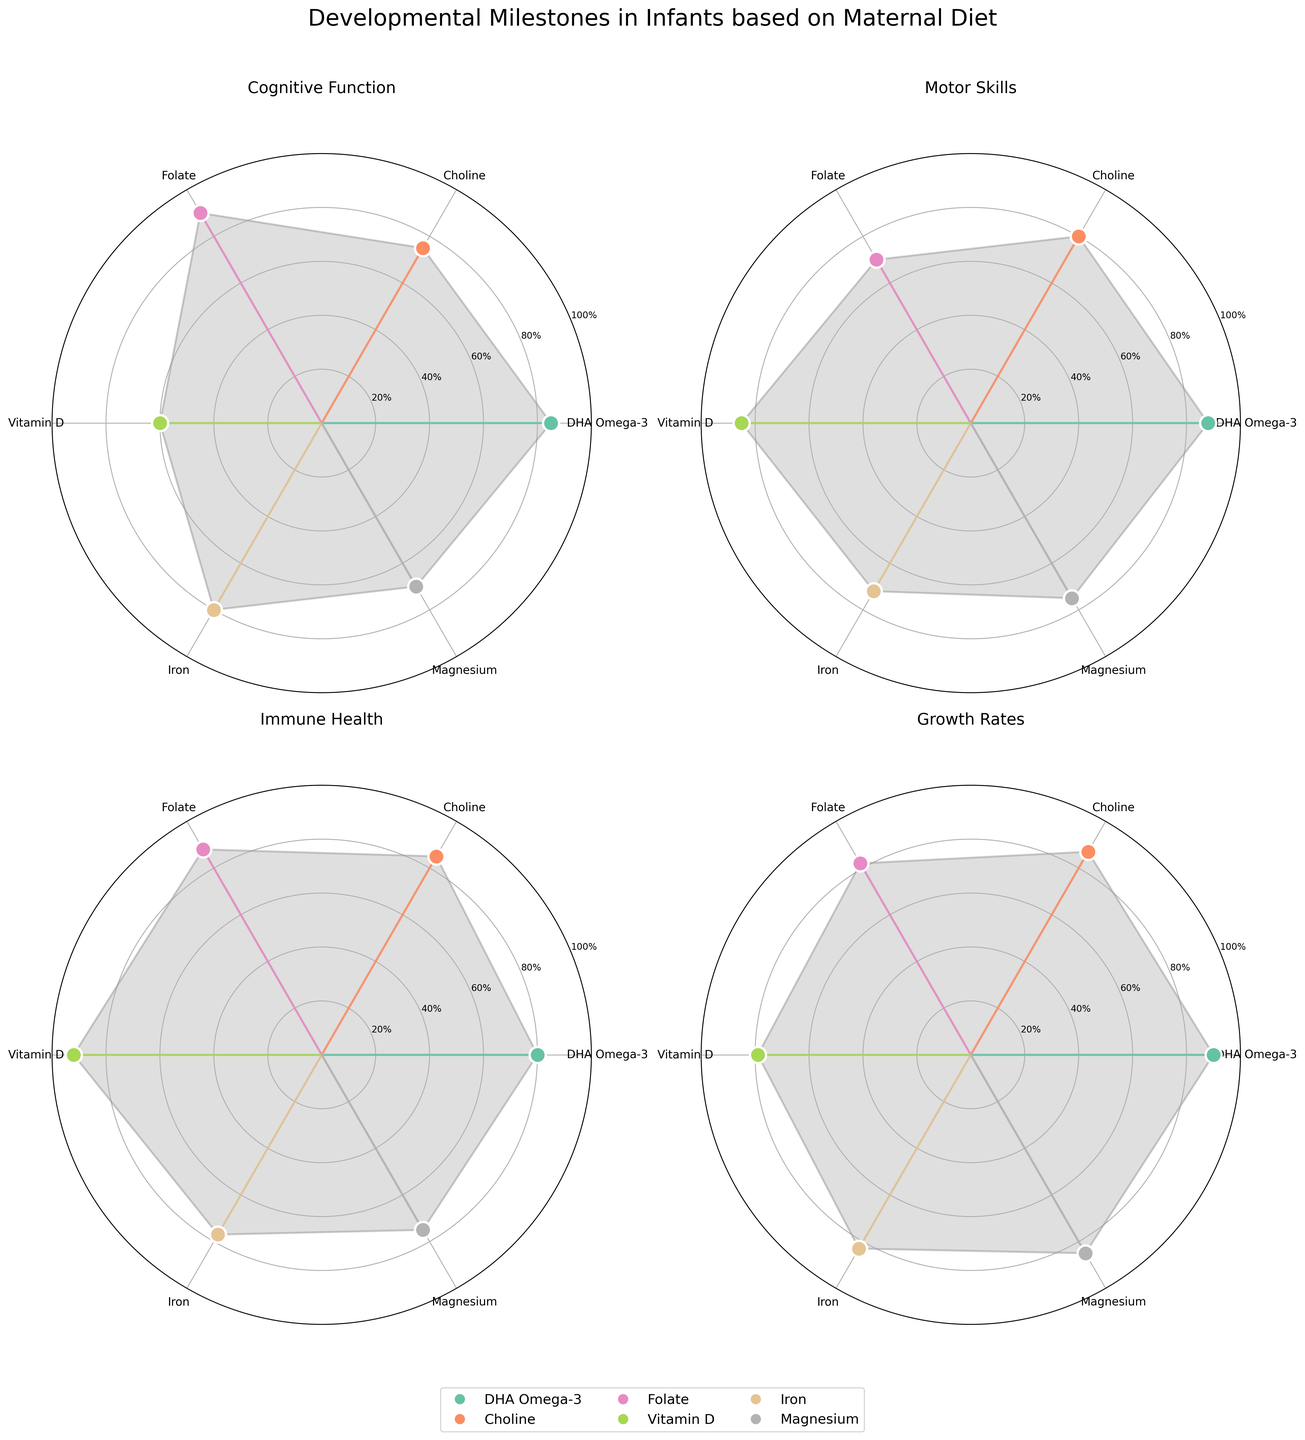What is the title of the figure? The title of the figure is displayed at the top of the plot.
Answer: Developmental Milestones in Infants based on Maternal Diet How many nutrient categories are there in each radar chart subplot? Each radar chart subplot has nutrient categories indicated by angles on the polar plot. Count these categories.
Answer: 6 Which nutrient shows the highest percentage for Cognitive Function? Look at the radar chart subplot for Cognitive Function and identify the nutrient with the highest value.
Answer: Folate (90%) What is the average percentage for Iron across all four developmental milestones? Sum the percentages of Iron for each developmental milestone and divide by 4.
Answer: (88 + 82 + 80 + 90)/4 = 85 Which two nutrients have the least and highest values in Motor Skills? Look at the radar chart subplot for Motor Skills and identify the nutrients with the smallest and largest values.
Answer: Calcium (70%) and Iron (88%) Compare the percentage values of Vitamin D for Immune Health and Growth Rates. Which one is higher? Check the values corresponding to Vitamin D in Immune Health and Growth Rates radar chart subplots and compare them.
Answer: 77% for Immune Health and 79% for Growth Rates, so Growth Rates is higher Are the percentage values of DHA Omega-3 higher in Cognitive Function or Motor Skills? Look at the radar chart subplots for Cognitive Function and Motor Skills to find and compare the percentage values given for DHA Omega-3.
Answer: 85% for Cognitive Function and 72% for Motor Skills, so Cognitive Function is higher What is the range of values for the nutrient 'Folate' across all categories? Identify the maximum and minimum percentage values for Folate across Cognitive Function, Motor Skills, Immune Health, and Growth Rates.
Answer: Highest: 90%, Lowest: 80%, Range: 90-80 = 10 Which nutrient has the most balanced (similar) percentage values across all four developmental milestones? Assess which nutrient's values are most consistent across Cognitive Function, Motor Skills, Immune Health, and Growth Rates.
Answer: Iron (values: 88, 82, 80, and 90) How is the value for Vitamin C in Motor Skills compared to Iodine in Immune Health? Compare the percentage values between Vitamin C in Motor Skills and Iodine in Immune Health.
Answer: Vitamin C (75%) is equal to Iodine (75%) 